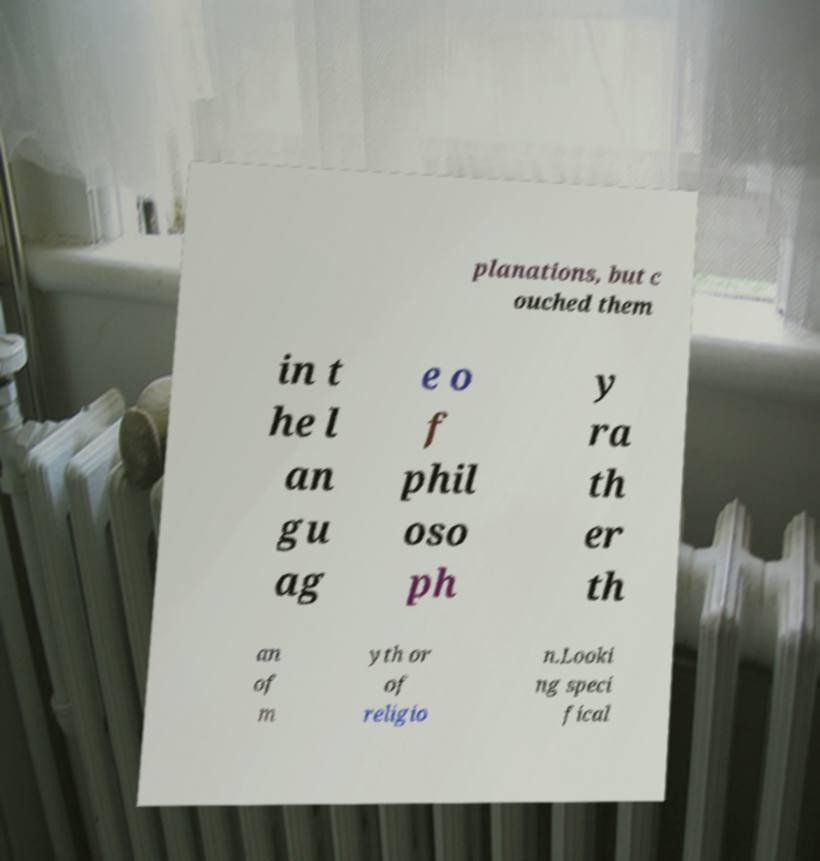I need the written content from this picture converted into text. Can you do that? planations, but c ouched them in t he l an gu ag e o f phil oso ph y ra th er th an of m yth or of religio n.Looki ng speci fical 